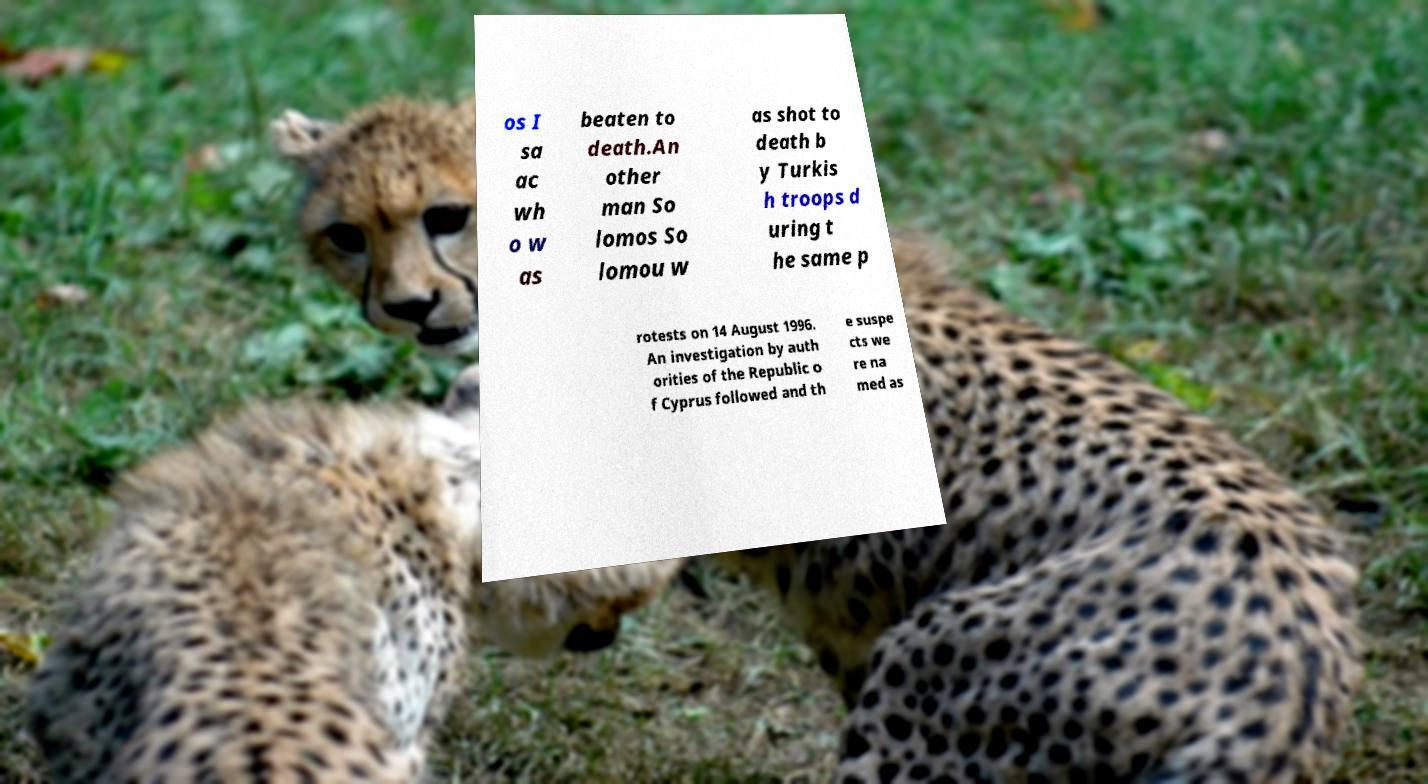Please identify and transcribe the text found in this image. os I sa ac wh o w as beaten to death.An other man So lomos So lomou w as shot to death b y Turkis h troops d uring t he same p rotests on 14 August 1996. An investigation by auth orities of the Republic o f Cyprus followed and th e suspe cts we re na med as 